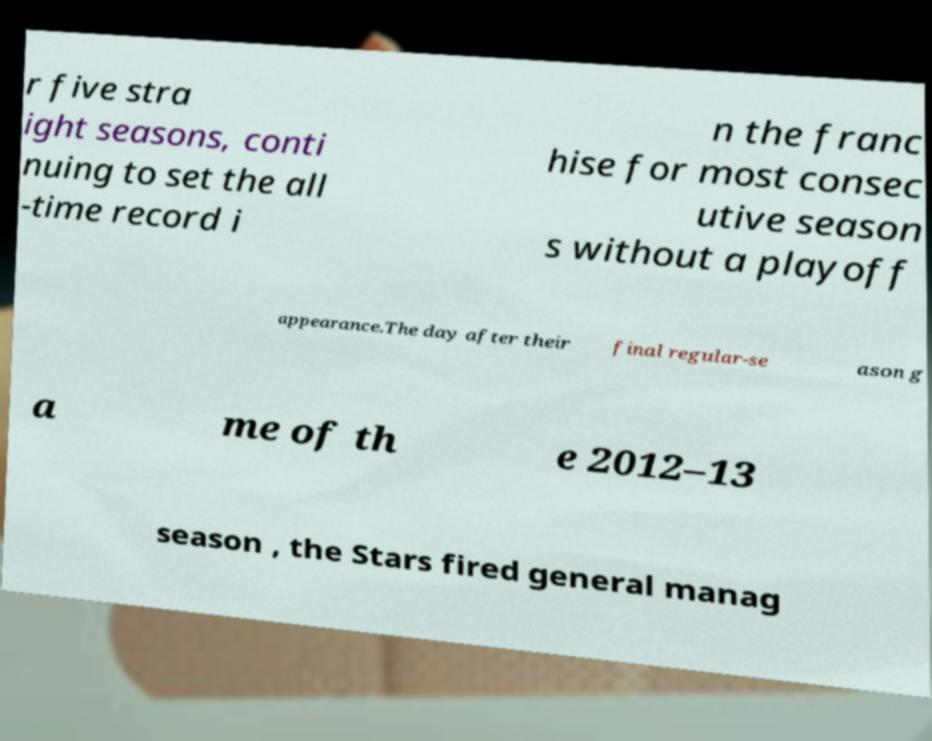Please identify and transcribe the text found in this image. r five stra ight seasons, conti nuing to set the all -time record i n the franc hise for most consec utive season s without a playoff appearance.The day after their final regular-se ason g a me of th e 2012–13 season , the Stars fired general manag 